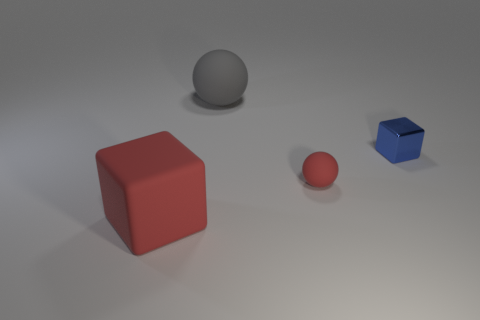Subtract all red spheres. How many spheres are left? 1 Add 4 tiny blue things. How many objects exist? 8 Subtract 2 spheres. How many spheres are left? 0 Subtract all gray balls. Subtract all green blocks. How many balls are left? 1 Subtract all green blocks. How many green spheres are left? 0 Subtract all green rubber spheres. Subtract all tiny spheres. How many objects are left? 3 Add 4 small red objects. How many small red objects are left? 5 Add 2 purple metallic cubes. How many purple metallic cubes exist? 2 Subtract 0 brown cylinders. How many objects are left? 4 